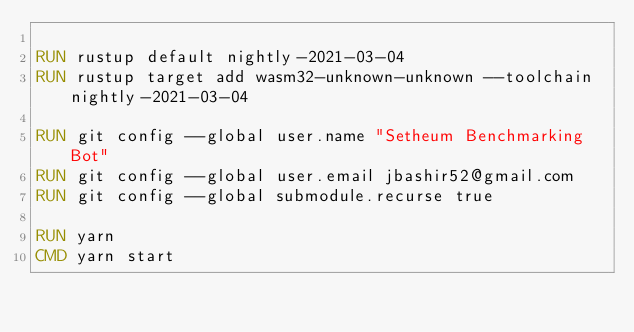Convert code to text. <code><loc_0><loc_0><loc_500><loc_500><_Dockerfile_>
RUN rustup default nightly-2021-03-04
RUN rustup target add wasm32-unknown-unknown --toolchain nightly-2021-03-04

RUN git config --global user.name "Setheum Benchmarking Bot"
RUN git config --global user.email jbashir52@gmail.com
RUN git config --global submodule.recurse true

RUN yarn
CMD yarn start
</code> 